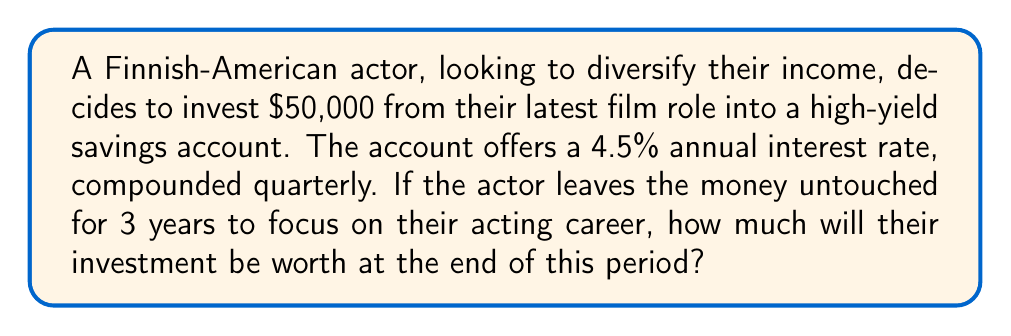Can you solve this math problem? To solve this problem, we'll use the compound interest formula:

$$A = P(1 + \frac{r}{n})^{nt}$$

Where:
$A$ = Final amount
$P$ = Principal (initial investment)
$r$ = Annual interest rate (as a decimal)
$n$ = Number of times interest is compounded per year
$t$ = Number of years

Given:
$P = \$50,000$
$r = 4.5\% = 0.045$
$n = 4$ (compounded quarterly)
$t = 3$ years

Let's substitute these values into the formula:

$$A = 50000(1 + \frac{0.045}{4})^{4 \cdot 3}$$

$$A = 50000(1 + 0.01125)^{12}$$

$$A = 50000(1.01125)^{12}$$

Using a calculator or computer:

$$A = 50000 \cdot 1.143371693$$

$$A = 57168.58$$

Rounding to the nearest cent:

$$A = \$57,168.58$$
Answer: $57,168.58 